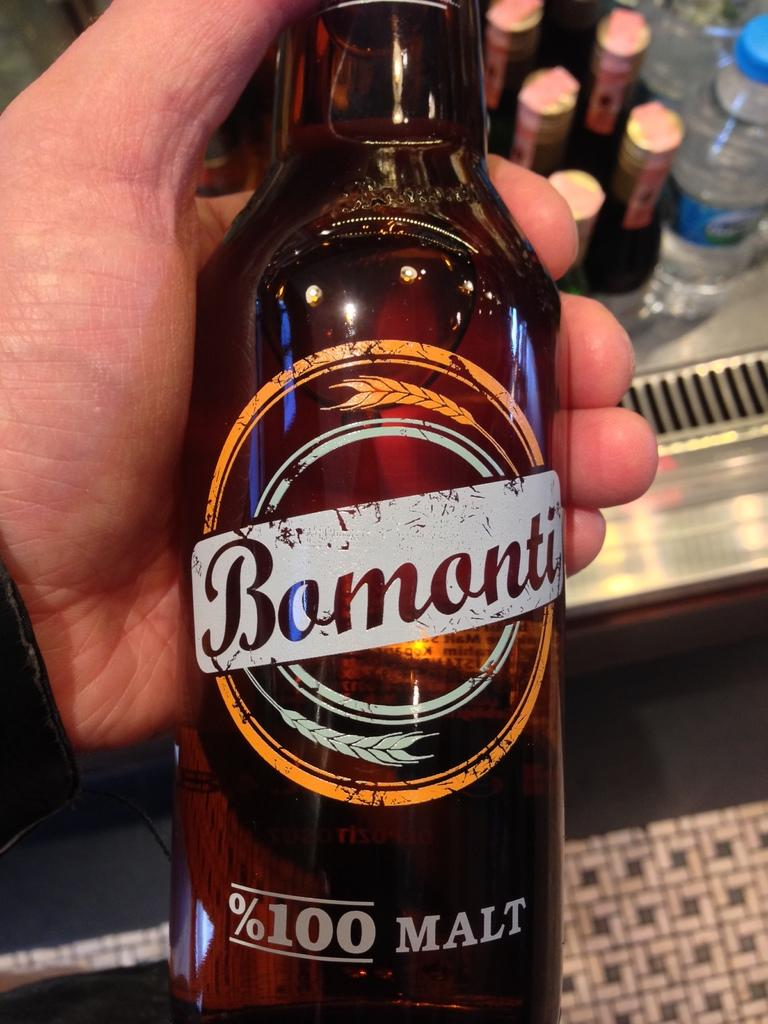What is the person holding in their hand in the image? There is a bottle in a person's hand in the image. Can you describe the background of the image? There are multiple bottles visible behind the person in the image. How many men are playing basketball in the image? There is no mention of men or basketball in the image; it only features a person holding a bottle and multiple bottles in the background. 